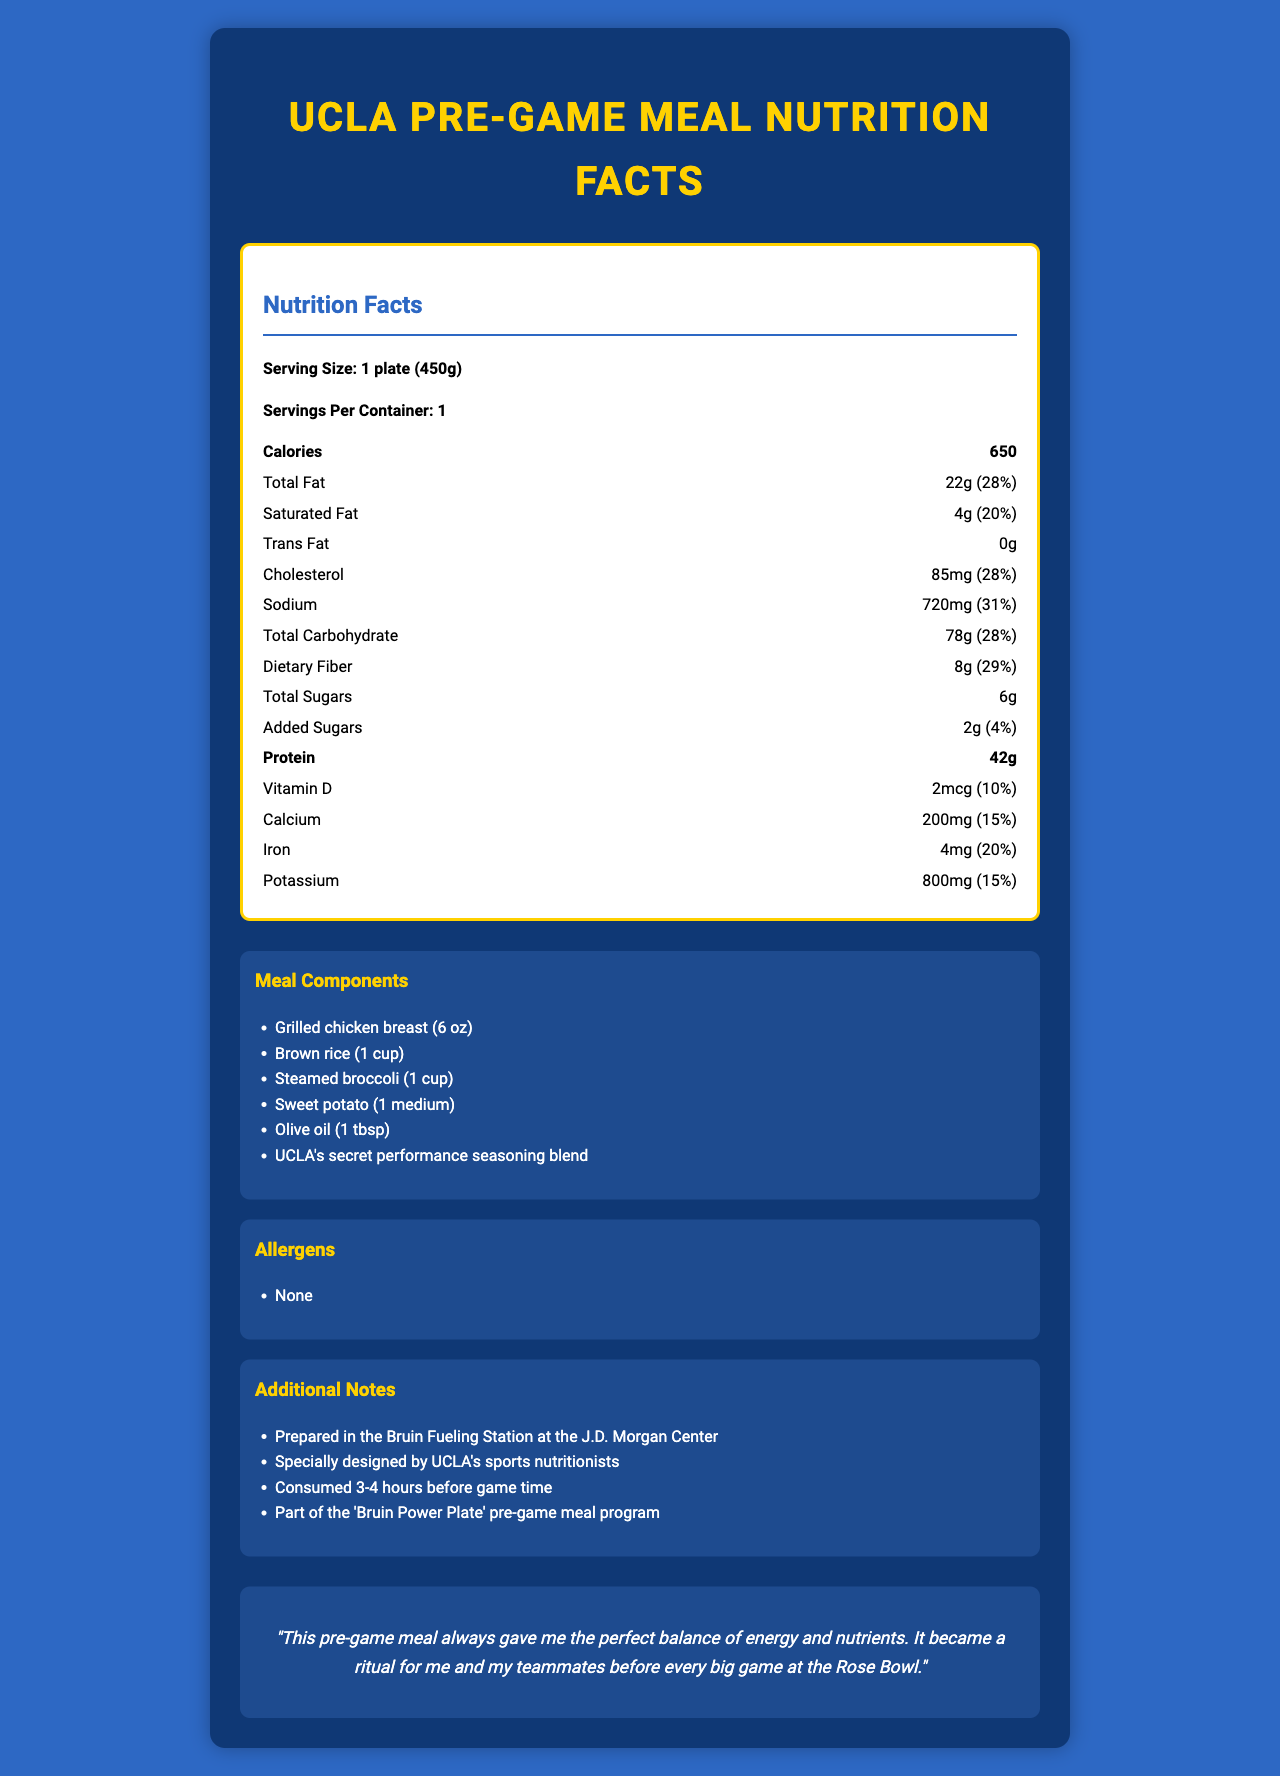what is the serving size of the meal? The nutrition label clearly states the serving size as "1 plate (450g)".
Answer: 1 plate (450g) how much protein does the pre-game meal contain? The document lists the protein content in the meal as 42g.
Answer: 42g what is the percentage daily value of dietary fiber in the meal? The nutrition label indicates that dietary fiber constitutes 29% of the daily value.
Answer: 29% which major component provides carbohydrates in this meal? A. Grilled chicken breast B. Brown rice C. Steamed broccoli Brown rice is known to be a carbohydrate-rich food compared to grilled chicken breast and steamed broccoli.
Answer: B how many milligrams of sodium are in the meal? The nutrition facts mention the sodium content as 720mg.
Answer: 720mg is there any trans fat in this meal? The document specifies the trans fat content as 0g.
Answer: No what are the main components of the pre-game meal? The meal components section lists these items.
Answer: Grilled chicken breast, Brown rice, Steamed broccoli, Sweet potato, Olive oil, UCLA's secret performance seasoning blend describe the purpose and timing of consumption for this pre-game meal. The additional notes section explains that the meal is consumed 3-4 hours before game time and is part of the 'Bruin Power Plate' program.
Answer: This pre-game meal is designed to provide athletes with a balance of energy and nutrients 3-4 hours before game time as part of the 'Bruin Power Plate' program. what type of fat makes up a larger portion of the total fat content? The total fat is 22g, with only 4g being saturated fat; hence, the rest (18g) is unsaturated fat.
Answer: Unsaturated fat which vitamin is present in this meal and what is its daily value percentage? A. Vitamin A (5%) B. Vitamin C (10%) C. Vitamin D (10%) The nutrition label indicates that the meal contains 2mcg of Vitamin D, which is 10% of the daily value.
Answer: C how many servings does this meal container provide? The document mentions that each container serves one plate.
Answer: 1 list all the additional notes mentioned in the document. The additional notes section outlines these details.
Answer: Prepared in the Bruin Fueling Station at the J.D. Morgan Center; Specially designed by UCLA's sports nutritionists; Consumed 3-4 hours before game time; Part of the 'Bruin Power Plate' pre-game meal program what general sentiment does the testimonial convey? The testimonial describes how the meal provided the perfect balance of energy and nutrients, making it a ritual before big games, which is a positive sentiment.
Answer: Positive does the document provide any information on allergens in the meal? The document clearly states that there are no allergens in the meal.
Answer: Yes which of the following does not contribute to the total carbohydrate content? A. Sweet potato B. Added sugars C. Grilled chicken breast D. Brown rice Grilled chicken breast is primarily a source of protein and does not contribute much to the carbohydrate content.
Answer: C who designed the meal and where is it prepared? The additional notes section mentions that the meal is designed by UCLA's sports nutritionists and prepared at the Bruin Fueling Station at the J.D. Morgan Center.
Answer: UCLA's sports nutritionists; Bruin Fueling Station at the J.D. Morgan Center how many grams of added sugars are included in the meal? The nutrition label specifies that there are 2g of added sugars in the meal.
Answer: 2g what is the primary purpose of this document? The document provides comprehensive nutrition facts, meal components, allergens, additional notes, and a testimonial for a pre-game meal program.
Answer: To provide detailed nutrition information and additional notes about a pre-game meal served at UCLA's training facility, designed for athletes’ optimal performance. how does the total carbohydrate content compare to the dietary fiber content? The nutrition label shows 78g of total carbohydrates and 8g of dietary fiber, which is part of the total carbohydrates.
Answer: The total carbohydrate content is 78g, while the dietary fiber content is 8g. This means dietary fiber constitutes a part of the total carbohydrates. what kind of oil is used in the meal preparation? The meal components list specifies 1 tablespoon of olive oil.
Answer: Olive oil is there any information provided about the vitamin A content in the meal? The document does not mention vitamin A in the nutrition facts.
Answer: Not enough information 